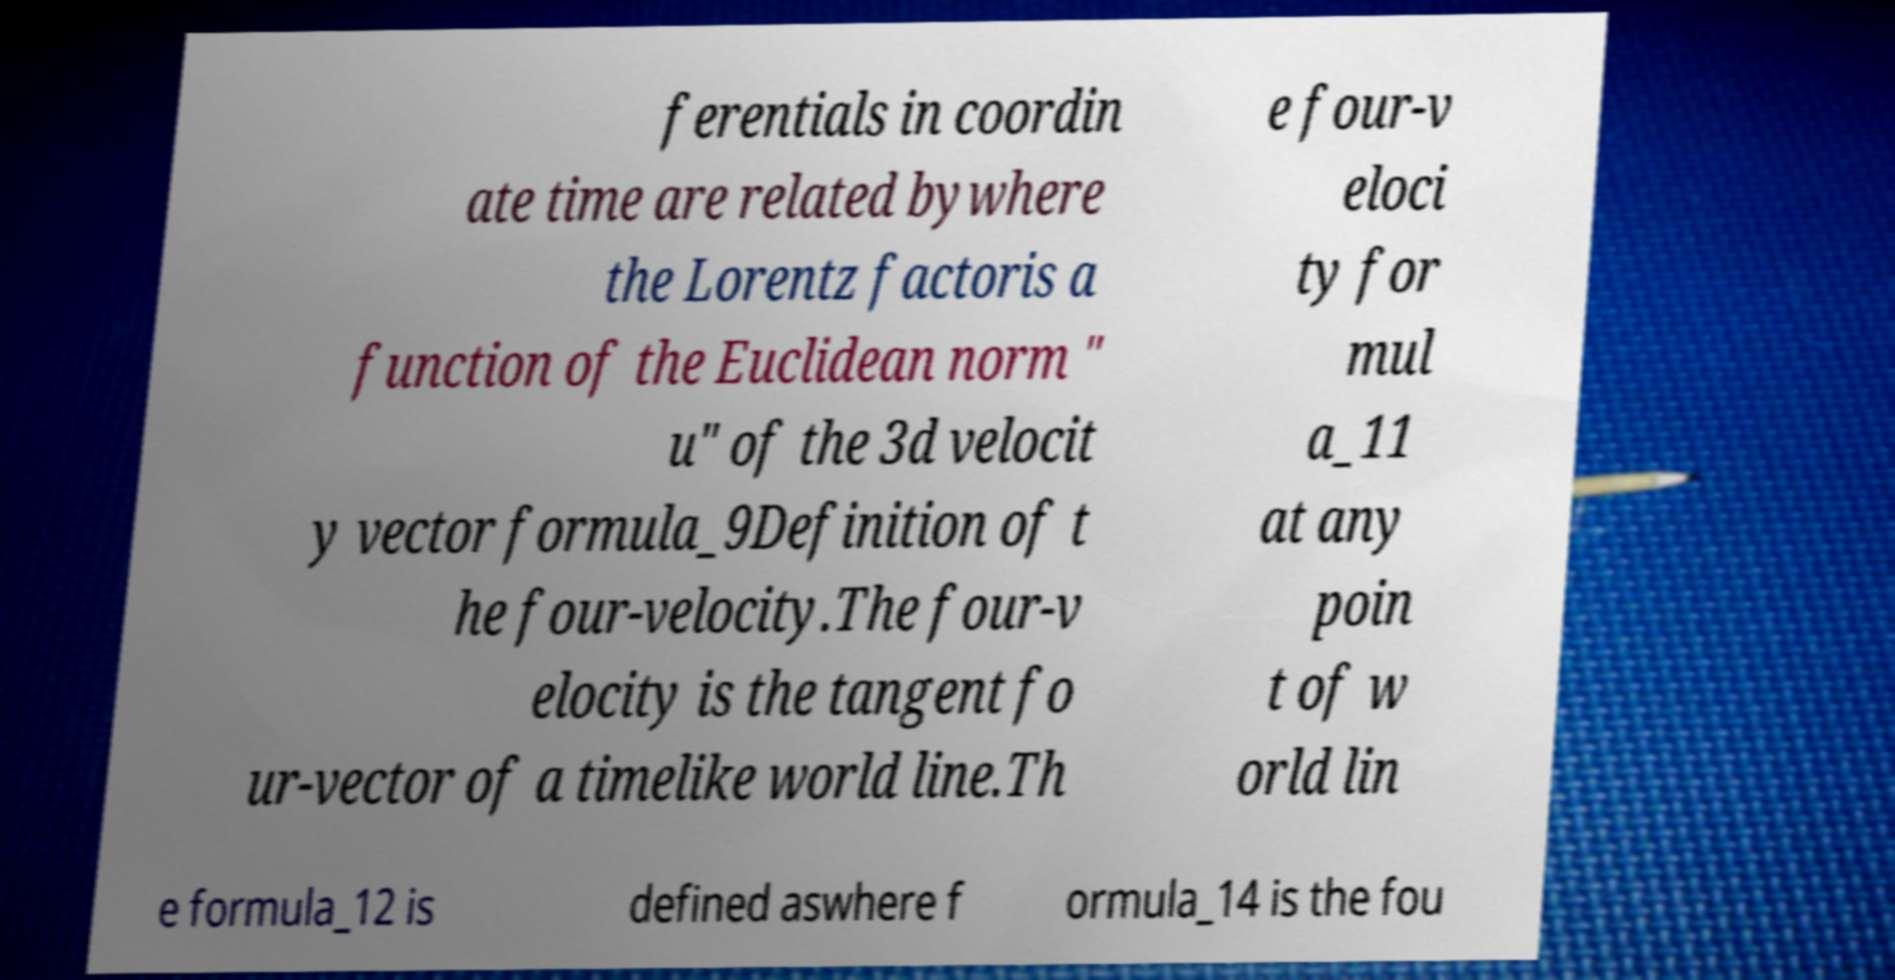Can you accurately transcribe the text from the provided image for me? ferentials in coordin ate time are related bywhere the Lorentz factoris a function of the Euclidean norm " u" of the 3d velocit y vector formula_9Definition of t he four-velocity.The four-v elocity is the tangent fo ur-vector of a timelike world line.Th e four-v eloci ty for mul a_11 at any poin t of w orld lin e formula_12 is defined aswhere f ormula_14 is the fou 